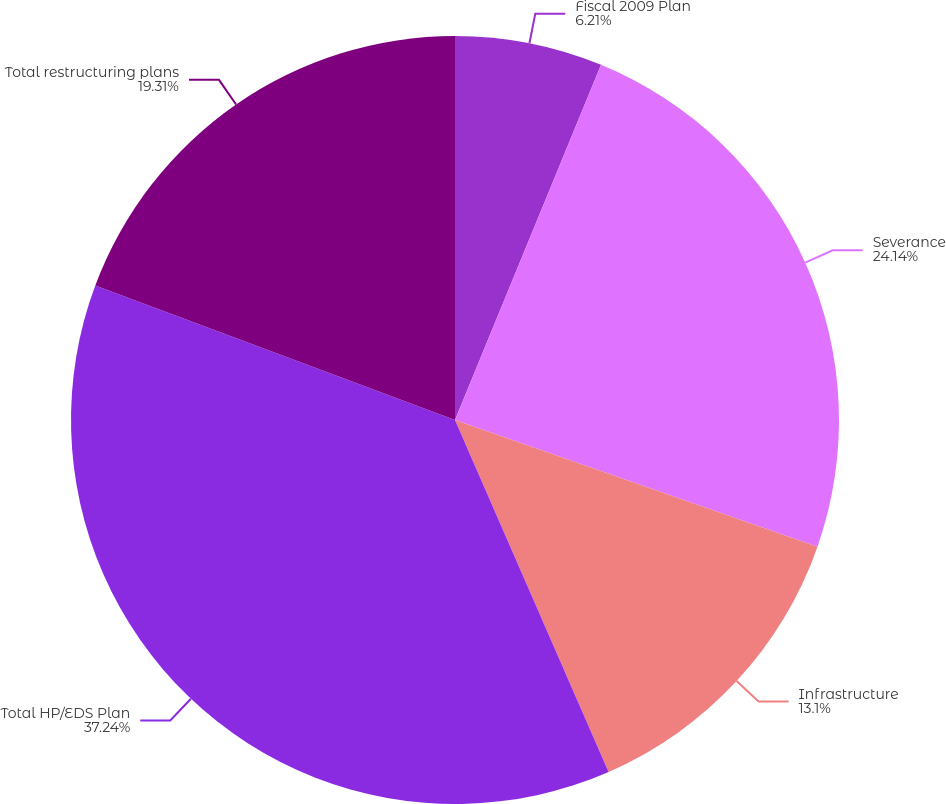<chart> <loc_0><loc_0><loc_500><loc_500><pie_chart><fcel>Fiscal 2009 Plan<fcel>Severance<fcel>Infrastructure<fcel>Total HP/EDS Plan<fcel>Total restructuring plans<nl><fcel>6.21%<fcel>24.14%<fcel>13.1%<fcel>37.24%<fcel>19.31%<nl></chart> 